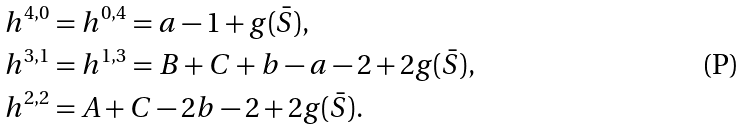Convert formula to latex. <formula><loc_0><loc_0><loc_500><loc_500>h ^ { 4 , 0 } & = h ^ { 0 , 4 } = a - 1 + g ( \bar { S } ) , \\ h ^ { 3 , 1 } & = h ^ { 1 , 3 } = B + C + b - a - 2 + 2 g ( \bar { S } ) , \\ h ^ { 2 , 2 } & = A + C - 2 b - 2 + 2 g ( \bar { S } ) .</formula> 